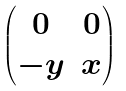Convert formula to latex. <formula><loc_0><loc_0><loc_500><loc_500>\begin{pmatrix} 0 & 0 \\ - y & x \end{pmatrix}</formula> 